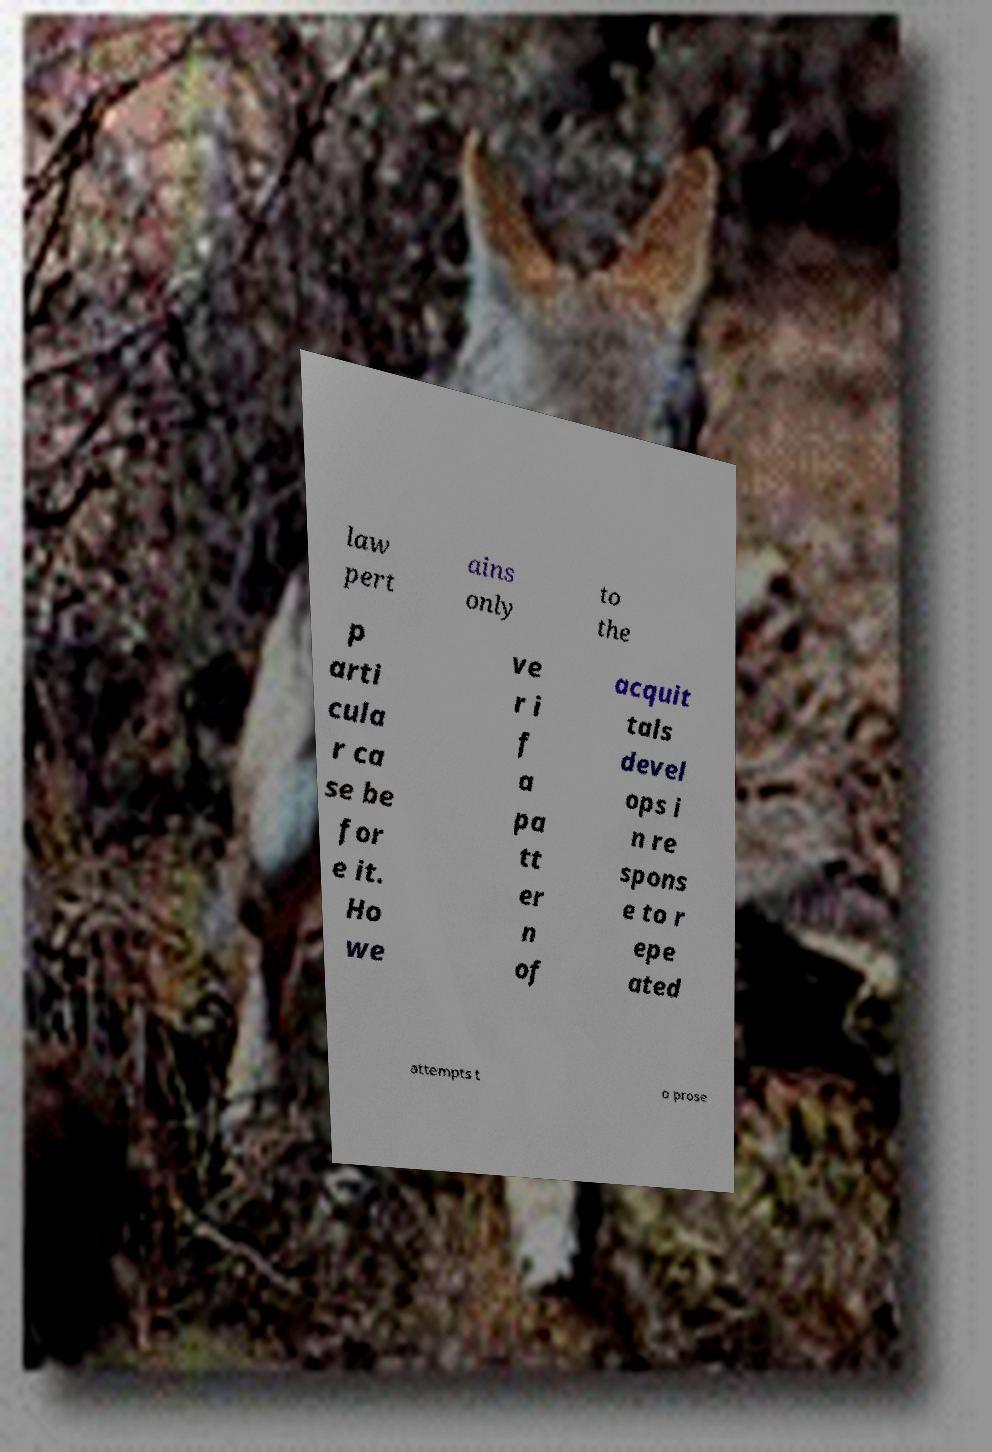There's text embedded in this image that I need extracted. Can you transcribe it verbatim? law pert ains only to the p arti cula r ca se be for e it. Ho we ve r i f a pa tt er n of acquit tals devel ops i n re spons e to r epe ated attempts t o prose 